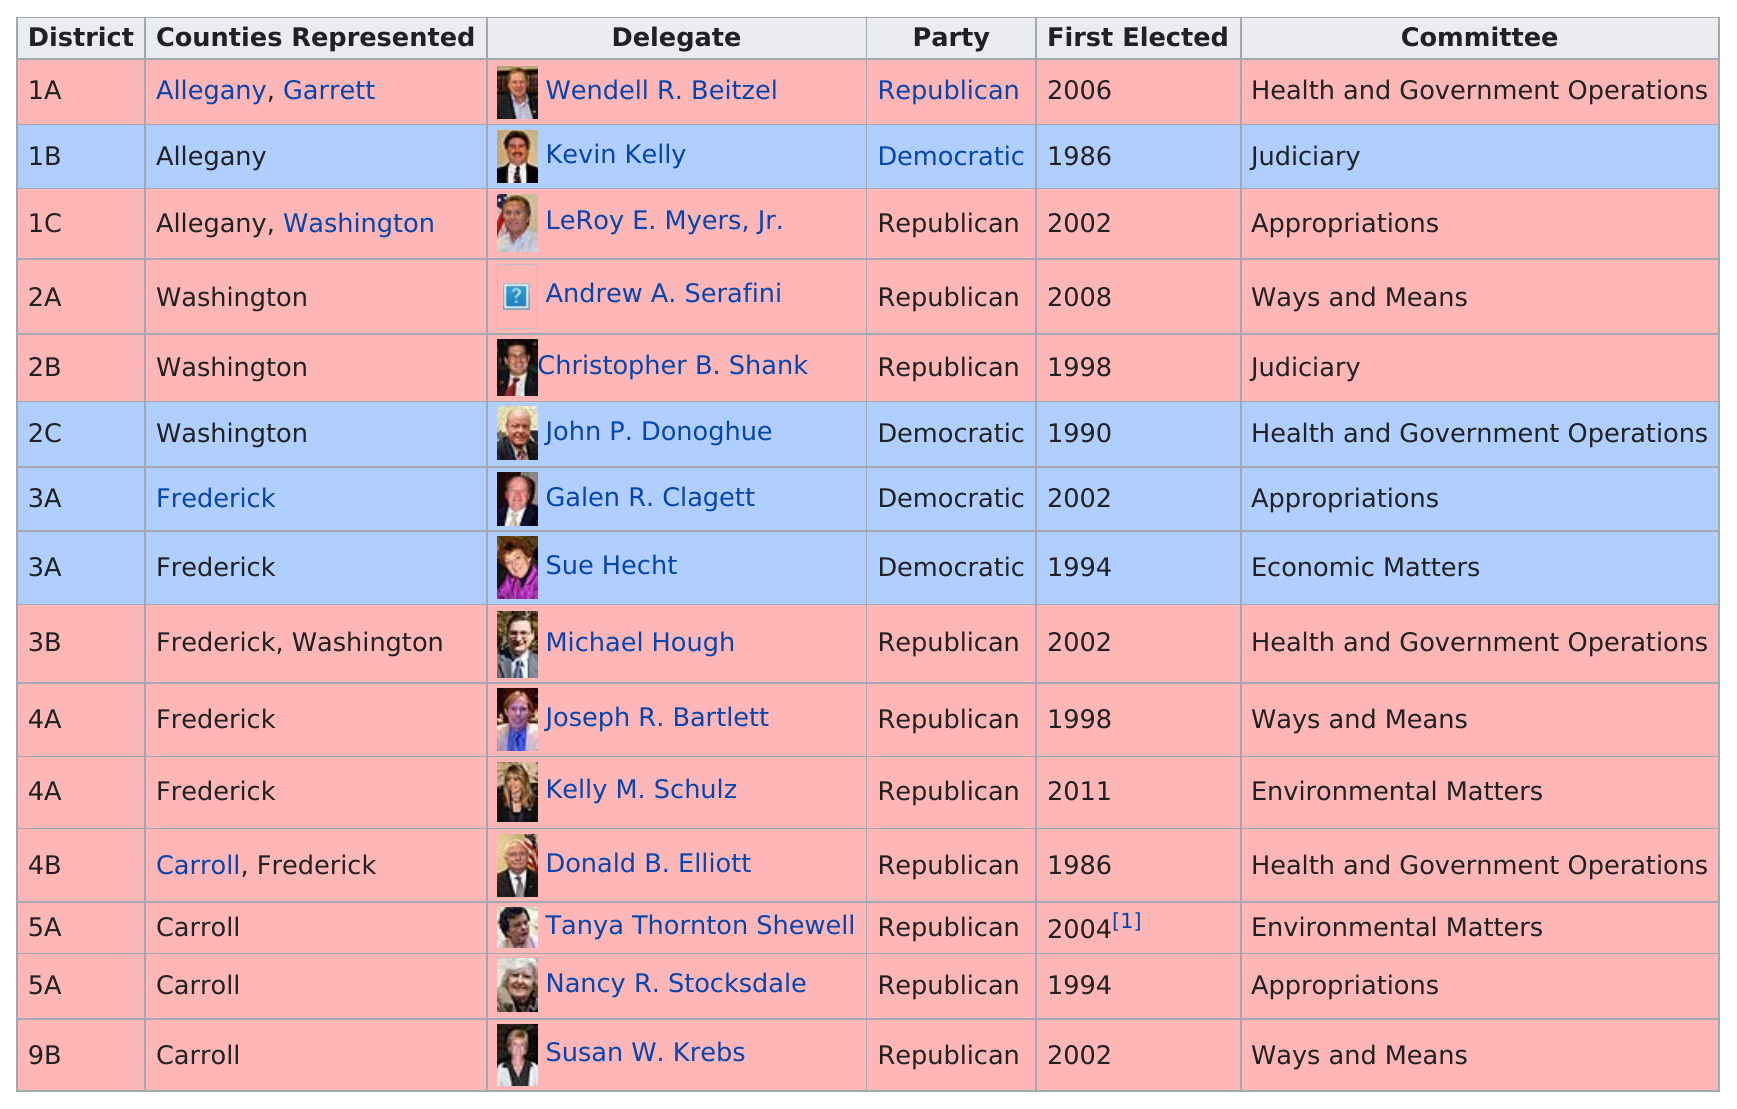Indicate a few pertinent items in this graphic. As of April 4th, the total amount of Democratic delegates is 4... There are a total of 6 different committees listed. The judiciary committee has appeared for delegates in the Republican Party a total of 1 times. In 2002, Galen R. Clagett was first elected to serve in the Western Maryland delegation. I seek to establish the number of delegates who are members of the Ways and Means Committee and represent Washington County. As of my knowledge cutoff of January 2023, there is 1 such delegate. 